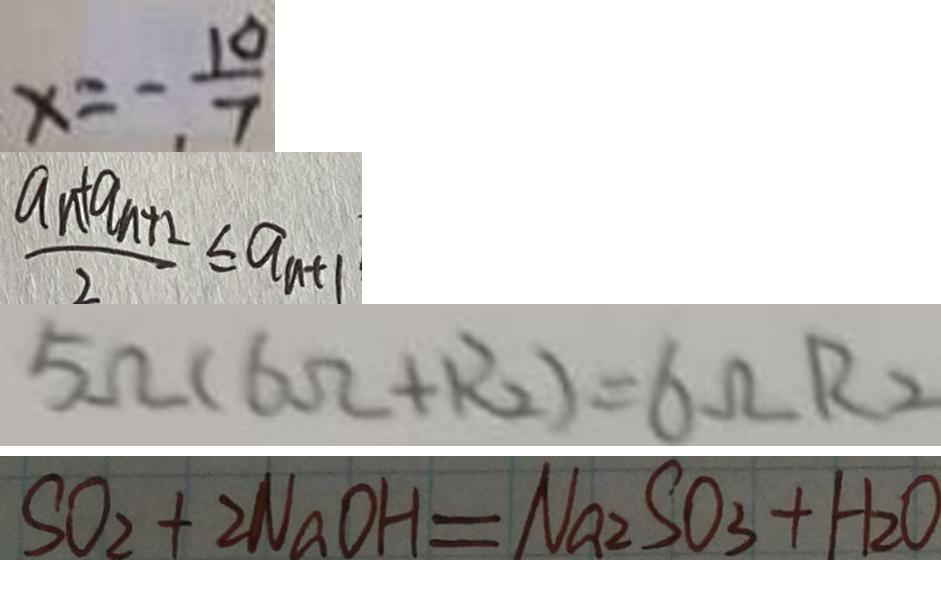Convert formula to latex. <formula><loc_0><loc_0><loc_500><loc_500>x = - \frac { 1 0 } { 7 } 
 \frac { a n + a _ { n + 2 } } { 2 } \leq a _ { n + 1 } 
 5 \Omega ( 6 \Omega + R _ { 2 } ) = 6 \Omega R _ { 2 } 
 S O _ { 2 } + 2 N a O H = N a _ { 2 } S O _ { 3 } + H _ { 2 } O</formula> 